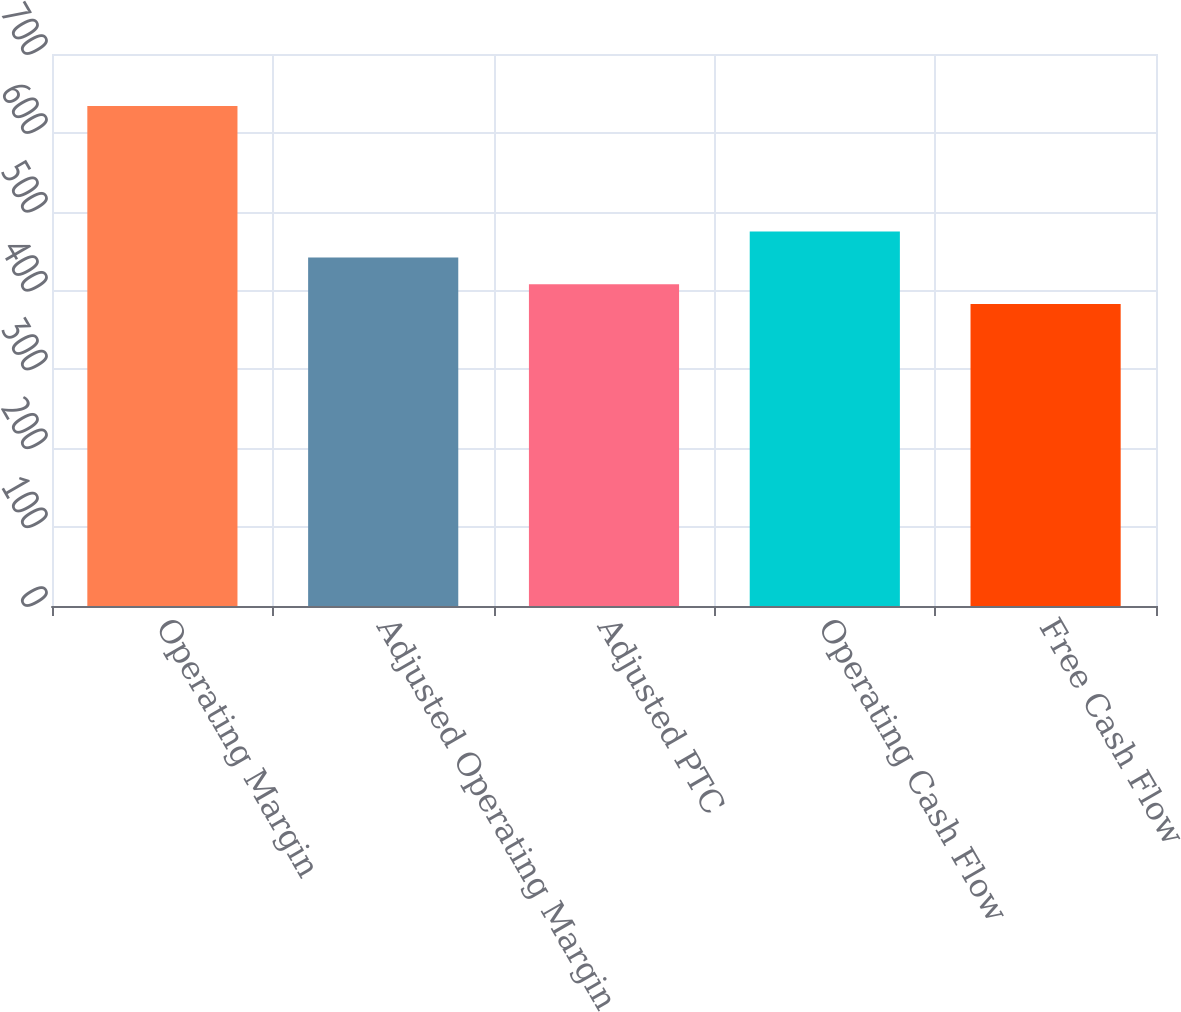<chart> <loc_0><loc_0><loc_500><loc_500><bar_chart><fcel>Operating Margin<fcel>Adjusted Operating Margin<fcel>Adjusted PTC<fcel>Operating Cash Flow<fcel>Free Cash Flow<nl><fcel>634<fcel>442<fcel>408.1<fcel>475<fcel>383<nl></chart> 